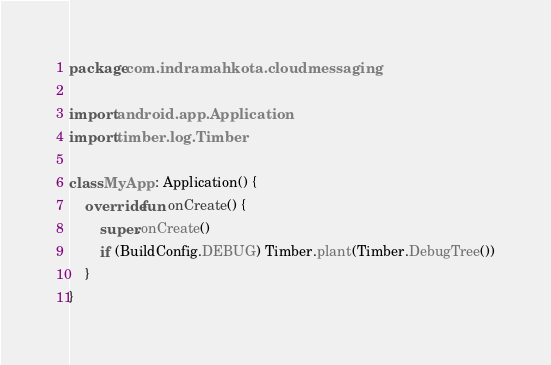Convert code to text. <code><loc_0><loc_0><loc_500><loc_500><_Kotlin_>package com.indramahkota.cloudmessaging

import android.app.Application
import timber.log.Timber

class MyApp : Application() {
    override fun onCreate() {
        super.onCreate()
        if (BuildConfig.DEBUG) Timber.plant(Timber.DebugTree())
    }
}</code> 